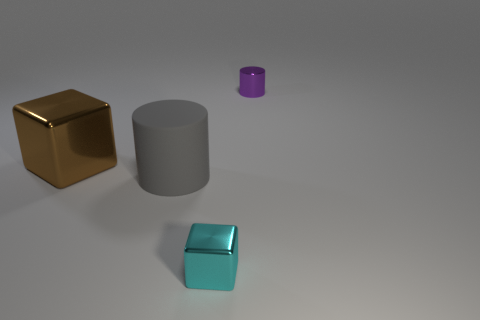Add 1 large brown metal cubes. How many objects exist? 5 Subtract all tiny things. Subtract all cyan objects. How many objects are left? 1 Add 2 gray rubber things. How many gray rubber things are left? 3 Add 4 small green matte cylinders. How many small green matte cylinders exist? 4 Subtract 0 blue cylinders. How many objects are left? 4 